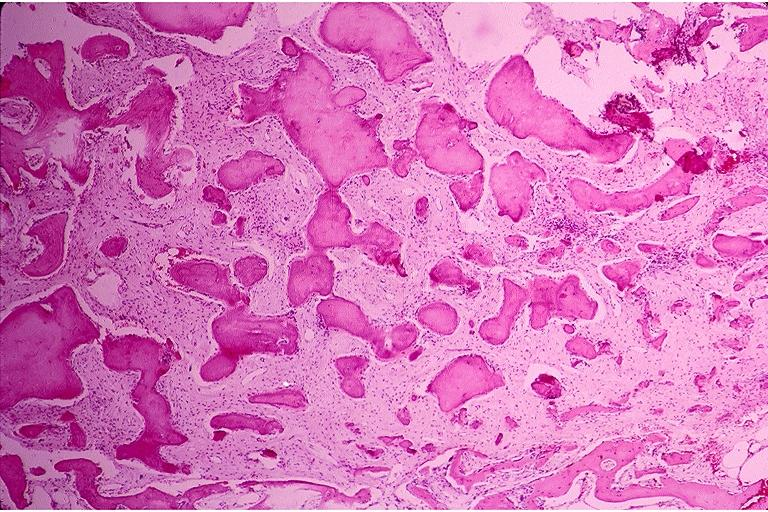s oral present?
Answer the question using a single word or phrase. Yes 